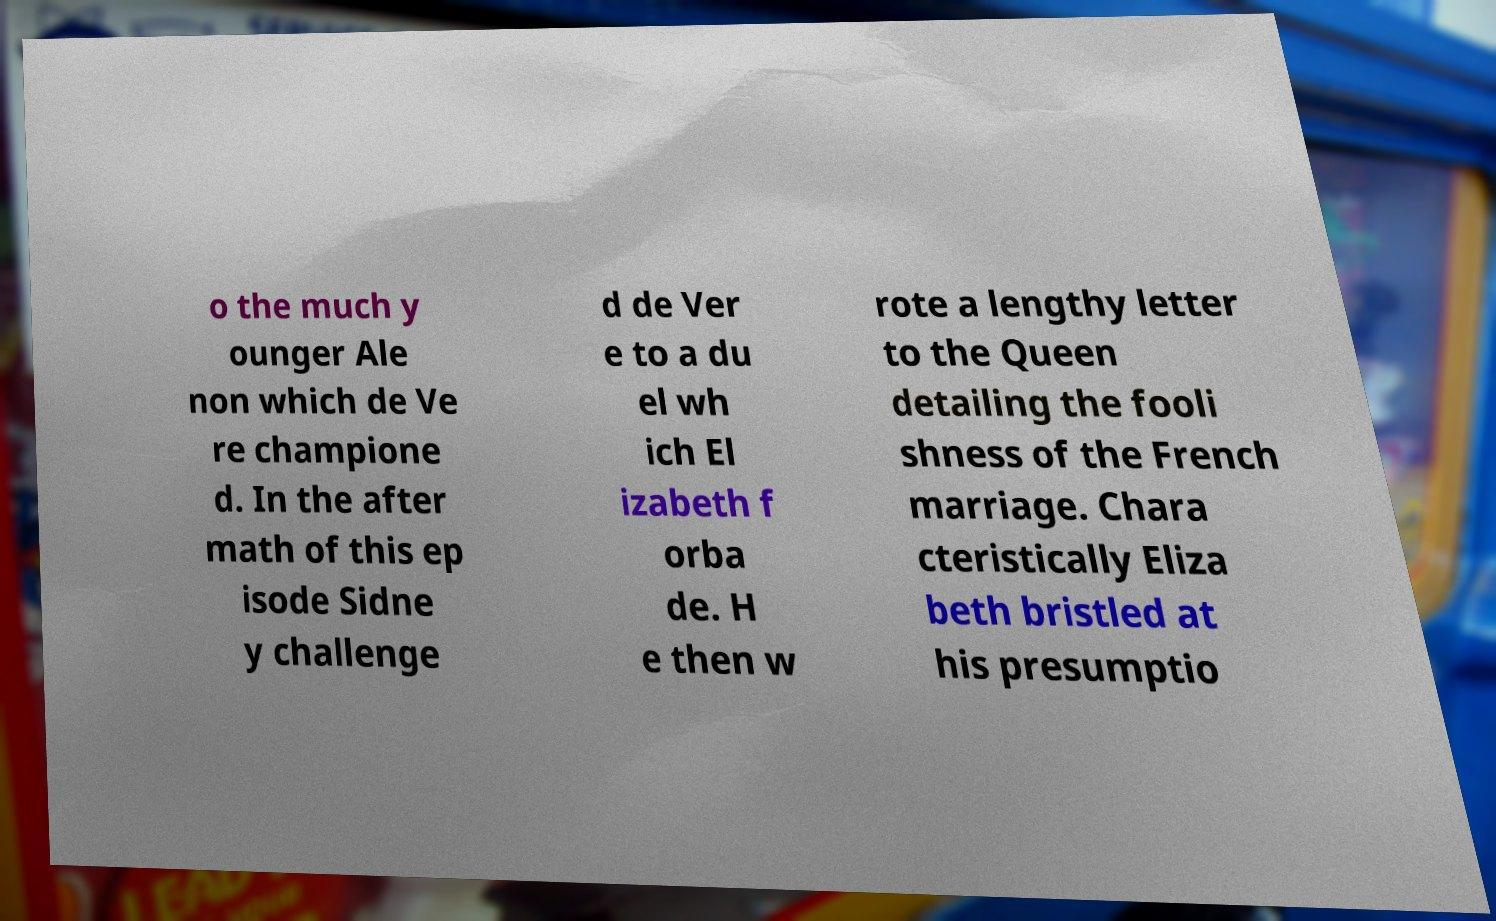There's text embedded in this image that I need extracted. Can you transcribe it verbatim? o the much y ounger Ale non which de Ve re champione d. In the after math of this ep isode Sidne y challenge d de Ver e to a du el wh ich El izabeth f orba de. H e then w rote a lengthy letter to the Queen detailing the fooli shness of the French marriage. Chara cteristically Eliza beth bristled at his presumptio 